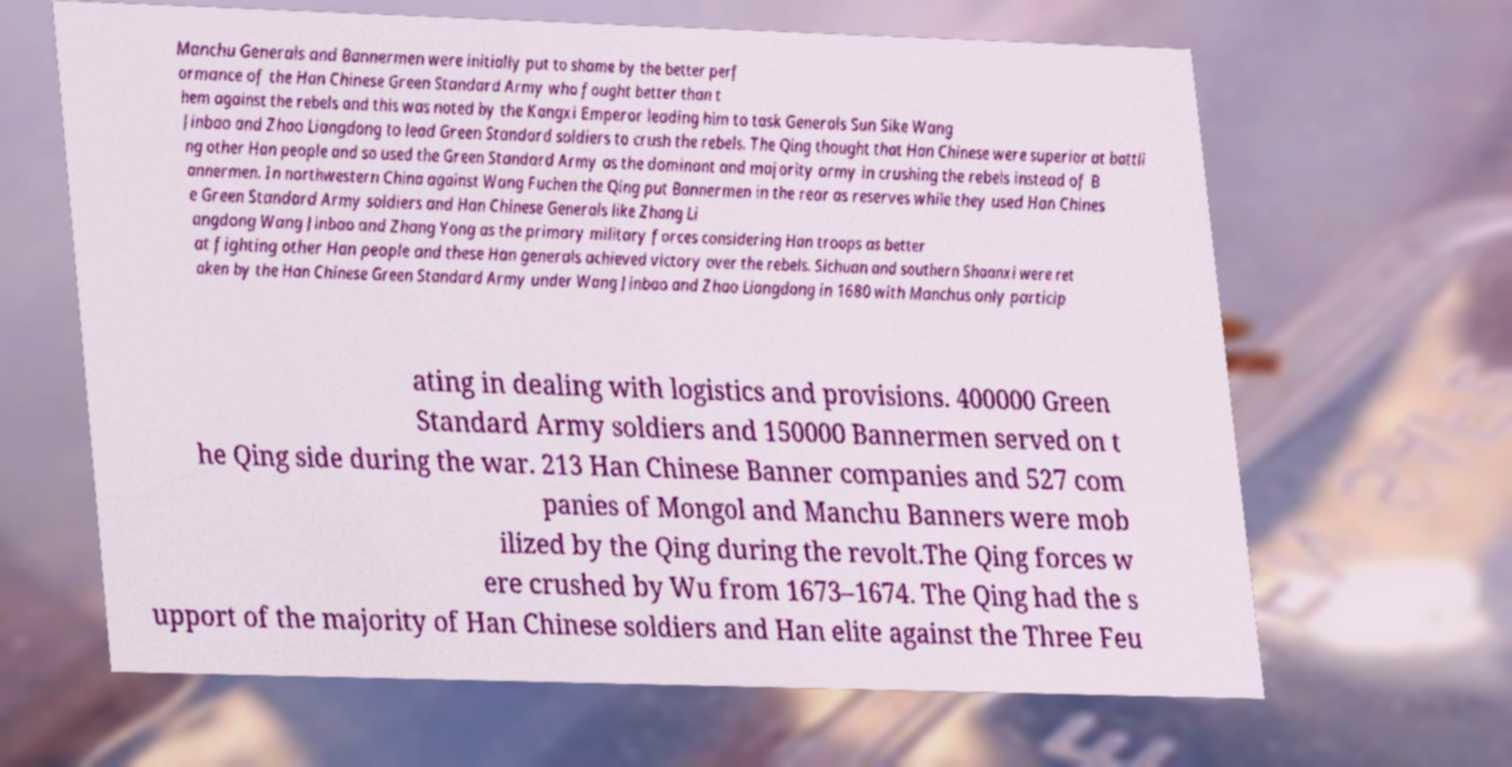Please read and relay the text visible in this image. What does it say? Manchu Generals and Bannermen were initially put to shame by the better perf ormance of the Han Chinese Green Standard Army who fought better than t hem against the rebels and this was noted by the Kangxi Emperor leading him to task Generals Sun Sike Wang Jinbao and Zhao Liangdong to lead Green Standard soldiers to crush the rebels. The Qing thought that Han Chinese were superior at battli ng other Han people and so used the Green Standard Army as the dominant and majority army in crushing the rebels instead of B annermen. In northwestern China against Wang Fuchen the Qing put Bannermen in the rear as reserves while they used Han Chines e Green Standard Army soldiers and Han Chinese Generals like Zhang Li angdong Wang Jinbao and Zhang Yong as the primary military forces considering Han troops as better at fighting other Han people and these Han generals achieved victory over the rebels. Sichuan and southern Shaanxi were ret aken by the Han Chinese Green Standard Army under Wang Jinbao and Zhao Liangdong in 1680 with Manchus only particip ating in dealing with logistics and provisions. 400000 Green Standard Army soldiers and 150000 Bannermen served on t he Qing side during the war. 213 Han Chinese Banner companies and 527 com panies of Mongol and Manchu Banners were mob ilized by the Qing during the revolt.The Qing forces w ere crushed by Wu from 1673–1674. The Qing had the s upport of the majority of Han Chinese soldiers and Han elite against the Three Feu 